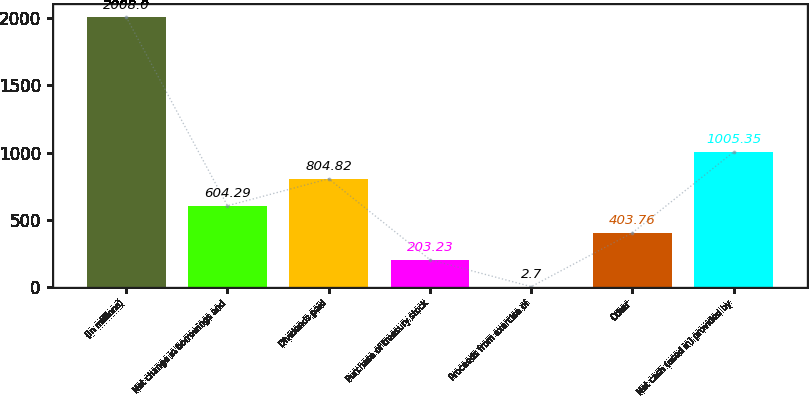Convert chart. <chart><loc_0><loc_0><loc_500><loc_500><bar_chart><fcel>(In millions)<fcel>Net change in borrowings and<fcel>Dividends paid<fcel>Purchase of treasury stock<fcel>Proceeds from exercise of<fcel>Other<fcel>Net cash (used in) provided by<nl><fcel>2008<fcel>604.29<fcel>804.82<fcel>203.23<fcel>2.7<fcel>403.76<fcel>1005.35<nl></chart> 